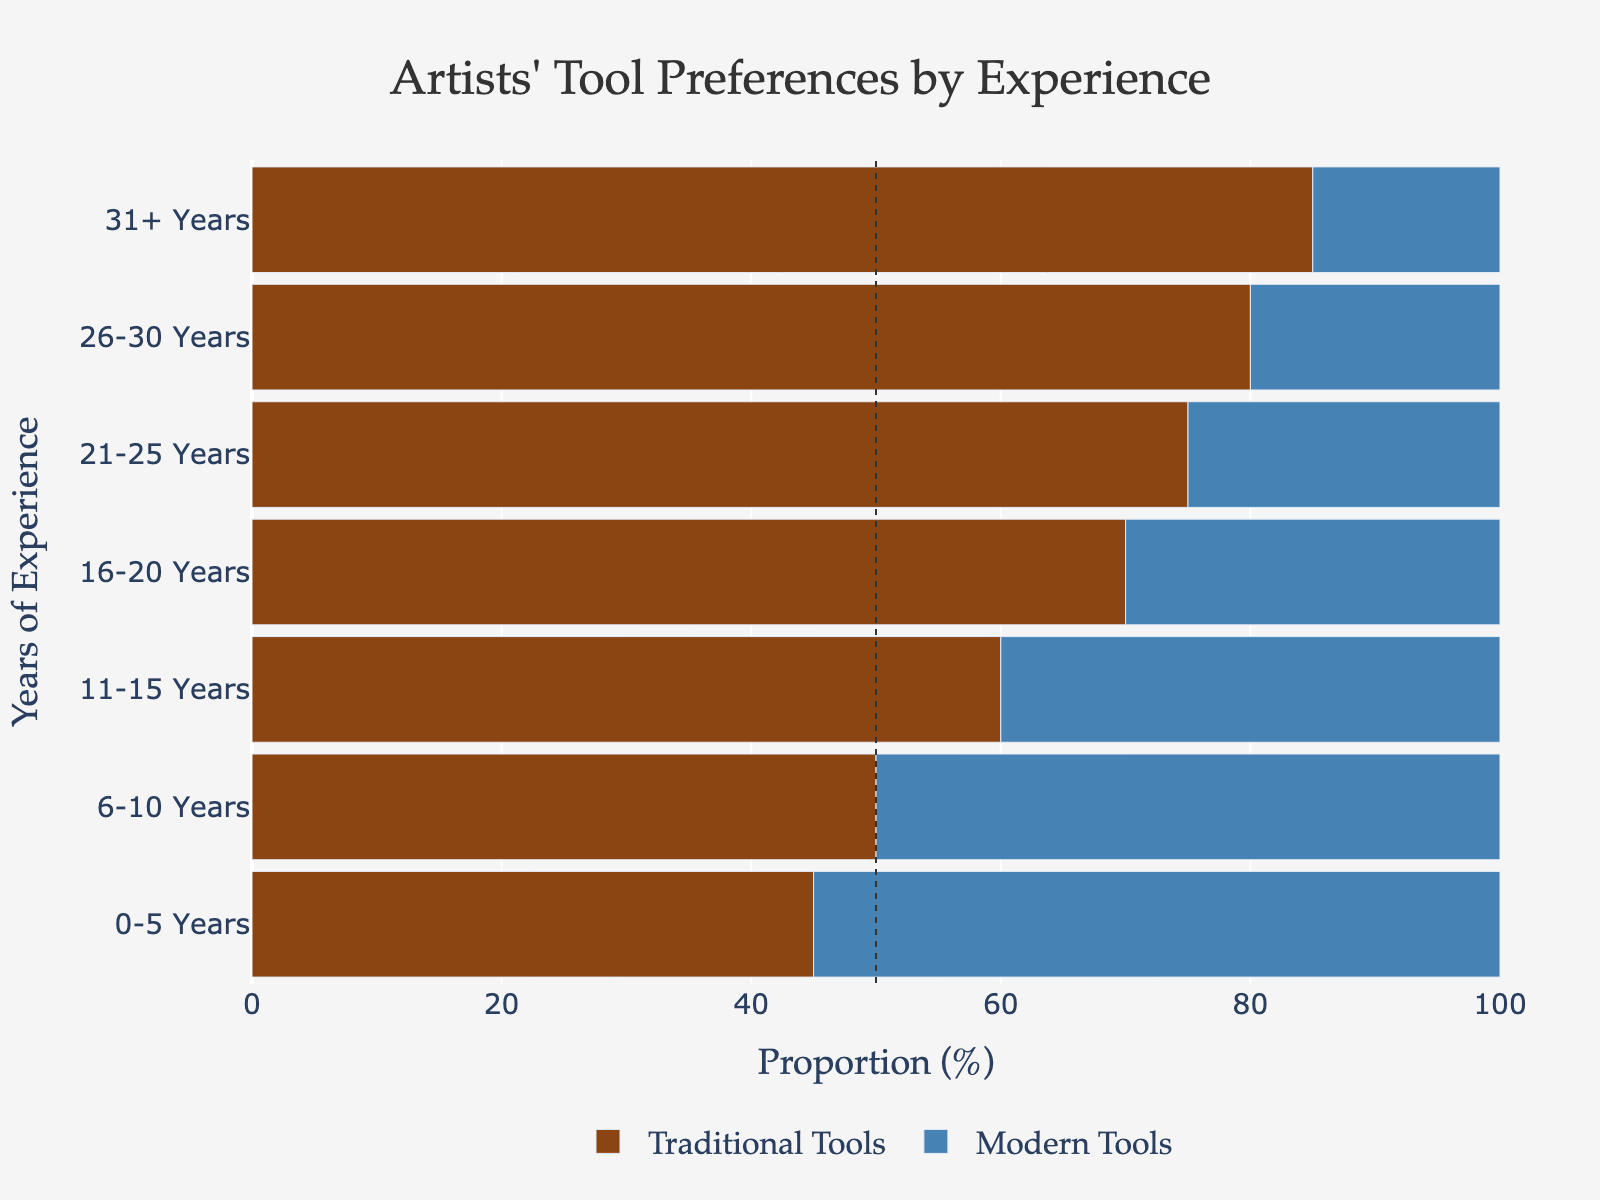What proportion of artists with 16-20 years of experience use modern tools? To find the proportion of artists with 16-20 years of experience using modern tools, look at the corresponding bar for "Modern Tools" in the chart for the "16-20 Years" category.
Answer: 30% Which group has the highest percentage of artists using traditional tools? By examining the length of the bars representing "Traditional Tools," you can see that the bar for the "31+ Years" category is the longest, indicating the highest percentage.
Answer: 31+ Years What is the average proportion of artists using traditional tools for 0-10 years of experience? To find the average proportion, add the traditional tools percentages for "0-5 Years" (45%) and "6-10 Years" (50%), then divide by 2. (45% + 50%) / 2 = 47.5%
Answer: 47.5% Is the proportion of artists using modern tools greater or less than those using traditional tools for 11-15 years of experience? Compare the bar lengths for "Traditional Tools" and "Modern Tools" in the "11-15 Years" category. The "Traditional Tools" bar is longer (60%) compared to the "Modern Tools" bar (40%).
Answer: Less How do the proportions of traditional and modern tools change as years of experience increase? Looking at the bars from left to right, the proportion of traditional tools increases while the proportion of modern tools decreases with more years of experience.
Answer: Traditional increases, Modern decreases Is there any group that has an equal proportion of artists using traditional and modern tools? Check for any categories where the bars for "Traditional Tools" and "Modern Tools" are of equal length. This occurs in the "6-10 Years" category, with both at 50%.
Answer: 6-10 Years What is the difference in the proportion of traditional tools between the least and most experienced groups? Subtract the proportion of traditional tools in the "0-5 Years" category (45%) from that in the "31+ Years" category (85%). 85% - 45% = 40%
Answer: 40% Which category has the smallest proportion of artists using modern tools? Look for the shortest bar representing "Modern Tools" which corresponds to the "31+ Years" category (15%).
Answer: 31+ Years 